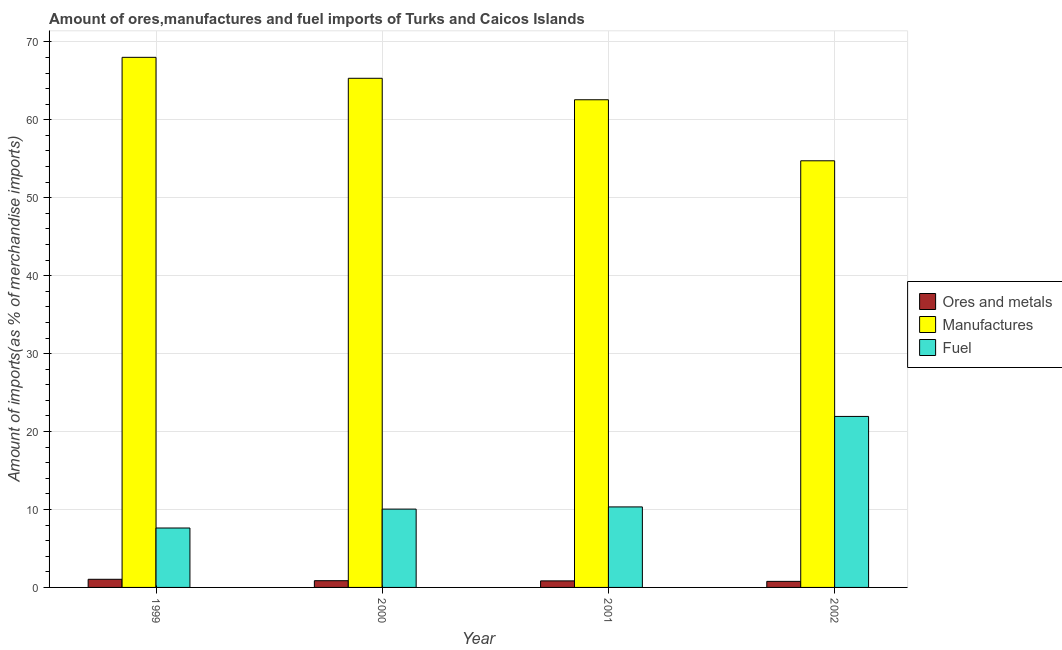How many different coloured bars are there?
Ensure brevity in your answer.  3. Are the number of bars on each tick of the X-axis equal?
Make the answer very short. Yes. How many bars are there on the 2nd tick from the left?
Offer a terse response. 3. How many bars are there on the 3rd tick from the right?
Make the answer very short. 3. What is the label of the 2nd group of bars from the left?
Your answer should be very brief. 2000. What is the percentage of manufactures imports in 2000?
Make the answer very short. 65.32. Across all years, what is the maximum percentage of fuel imports?
Your answer should be very brief. 21.94. Across all years, what is the minimum percentage of manufactures imports?
Give a very brief answer. 54.74. In which year was the percentage of ores and metals imports maximum?
Offer a terse response. 1999. What is the total percentage of manufactures imports in the graph?
Provide a succinct answer. 250.65. What is the difference between the percentage of manufactures imports in 2001 and that in 2002?
Offer a terse response. 7.83. What is the difference between the percentage of manufactures imports in 2001 and the percentage of fuel imports in 2002?
Provide a succinct answer. 7.83. What is the average percentage of ores and metals imports per year?
Make the answer very short. 0.88. In the year 2001, what is the difference between the percentage of fuel imports and percentage of ores and metals imports?
Ensure brevity in your answer.  0. What is the ratio of the percentage of manufactures imports in 1999 to that in 2000?
Provide a short and direct response. 1.04. What is the difference between the highest and the second highest percentage of fuel imports?
Your response must be concise. 11.61. What is the difference between the highest and the lowest percentage of fuel imports?
Your answer should be very brief. 14.31. Is the sum of the percentage of manufactures imports in 1999 and 2002 greater than the maximum percentage of ores and metals imports across all years?
Provide a succinct answer. Yes. What does the 1st bar from the left in 1999 represents?
Make the answer very short. Ores and metals. What does the 2nd bar from the right in 1999 represents?
Your response must be concise. Manufactures. How many years are there in the graph?
Your answer should be compact. 4. Does the graph contain grids?
Make the answer very short. Yes. What is the title of the graph?
Your response must be concise. Amount of ores,manufactures and fuel imports of Turks and Caicos Islands. Does "Slovak Republic" appear as one of the legend labels in the graph?
Provide a short and direct response. No. What is the label or title of the Y-axis?
Your response must be concise. Amount of imports(as % of merchandise imports). What is the Amount of imports(as % of merchandise imports) in Ores and metals in 1999?
Offer a very short reply. 1.04. What is the Amount of imports(as % of merchandise imports) of Manufactures in 1999?
Make the answer very short. 68.01. What is the Amount of imports(as % of merchandise imports) of Fuel in 1999?
Offer a terse response. 7.62. What is the Amount of imports(as % of merchandise imports) in Ores and metals in 2000?
Provide a short and direct response. 0.86. What is the Amount of imports(as % of merchandise imports) in Manufactures in 2000?
Your answer should be very brief. 65.32. What is the Amount of imports(as % of merchandise imports) of Fuel in 2000?
Give a very brief answer. 10.05. What is the Amount of imports(as % of merchandise imports) of Ores and metals in 2001?
Your response must be concise. 0.84. What is the Amount of imports(as % of merchandise imports) in Manufactures in 2001?
Your answer should be very brief. 62.57. What is the Amount of imports(as % of merchandise imports) of Fuel in 2001?
Provide a succinct answer. 10.33. What is the Amount of imports(as % of merchandise imports) in Ores and metals in 2002?
Provide a short and direct response. 0.78. What is the Amount of imports(as % of merchandise imports) of Manufactures in 2002?
Provide a succinct answer. 54.74. What is the Amount of imports(as % of merchandise imports) in Fuel in 2002?
Make the answer very short. 21.94. Across all years, what is the maximum Amount of imports(as % of merchandise imports) in Ores and metals?
Give a very brief answer. 1.04. Across all years, what is the maximum Amount of imports(as % of merchandise imports) of Manufactures?
Your answer should be very brief. 68.01. Across all years, what is the maximum Amount of imports(as % of merchandise imports) in Fuel?
Ensure brevity in your answer.  21.94. Across all years, what is the minimum Amount of imports(as % of merchandise imports) of Ores and metals?
Give a very brief answer. 0.78. Across all years, what is the minimum Amount of imports(as % of merchandise imports) of Manufactures?
Offer a very short reply. 54.74. Across all years, what is the minimum Amount of imports(as % of merchandise imports) in Fuel?
Provide a succinct answer. 7.62. What is the total Amount of imports(as % of merchandise imports) of Ores and metals in the graph?
Provide a short and direct response. 3.52. What is the total Amount of imports(as % of merchandise imports) in Manufactures in the graph?
Offer a very short reply. 250.65. What is the total Amount of imports(as % of merchandise imports) in Fuel in the graph?
Provide a short and direct response. 49.94. What is the difference between the Amount of imports(as % of merchandise imports) in Ores and metals in 1999 and that in 2000?
Your answer should be compact. 0.18. What is the difference between the Amount of imports(as % of merchandise imports) of Manufactures in 1999 and that in 2000?
Make the answer very short. 2.69. What is the difference between the Amount of imports(as % of merchandise imports) in Fuel in 1999 and that in 2000?
Your answer should be compact. -2.43. What is the difference between the Amount of imports(as % of merchandise imports) in Ores and metals in 1999 and that in 2001?
Your response must be concise. 0.2. What is the difference between the Amount of imports(as % of merchandise imports) of Manufactures in 1999 and that in 2001?
Offer a terse response. 5.44. What is the difference between the Amount of imports(as % of merchandise imports) of Fuel in 1999 and that in 2001?
Make the answer very short. -2.71. What is the difference between the Amount of imports(as % of merchandise imports) of Ores and metals in 1999 and that in 2002?
Make the answer very short. 0.27. What is the difference between the Amount of imports(as % of merchandise imports) of Manufactures in 1999 and that in 2002?
Your response must be concise. 13.27. What is the difference between the Amount of imports(as % of merchandise imports) of Fuel in 1999 and that in 2002?
Offer a terse response. -14.31. What is the difference between the Amount of imports(as % of merchandise imports) in Ores and metals in 2000 and that in 2001?
Provide a short and direct response. 0.02. What is the difference between the Amount of imports(as % of merchandise imports) in Manufactures in 2000 and that in 2001?
Make the answer very short. 2.75. What is the difference between the Amount of imports(as % of merchandise imports) of Fuel in 2000 and that in 2001?
Your response must be concise. -0.28. What is the difference between the Amount of imports(as % of merchandise imports) of Ores and metals in 2000 and that in 2002?
Ensure brevity in your answer.  0.08. What is the difference between the Amount of imports(as % of merchandise imports) of Manufactures in 2000 and that in 2002?
Give a very brief answer. 10.58. What is the difference between the Amount of imports(as % of merchandise imports) of Fuel in 2000 and that in 2002?
Keep it short and to the point. -11.89. What is the difference between the Amount of imports(as % of merchandise imports) in Ores and metals in 2001 and that in 2002?
Your response must be concise. 0.06. What is the difference between the Amount of imports(as % of merchandise imports) of Manufactures in 2001 and that in 2002?
Keep it short and to the point. 7.83. What is the difference between the Amount of imports(as % of merchandise imports) in Fuel in 2001 and that in 2002?
Ensure brevity in your answer.  -11.61. What is the difference between the Amount of imports(as % of merchandise imports) of Ores and metals in 1999 and the Amount of imports(as % of merchandise imports) of Manufactures in 2000?
Make the answer very short. -64.28. What is the difference between the Amount of imports(as % of merchandise imports) in Ores and metals in 1999 and the Amount of imports(as % of merchandise imports) in Fuel in 2000?
Ensure brevity in your answer.  -9. What is the difference between the Amount of imports(as % of merchandise imports) in Manufactures in 1999 and the Amount of imports(as % of merchandise imports) in Fuel in 2000?
Make the answer very short. 57.96. What is the difference between the Amount of imports(as % of merchandise imports) of Ores and metals in 1999 and the Amount of imports(as % of merchandise imports) of Manufactures in 2001?
Provide a short and direct response. -61.53. What is the difference between the Amount of imports(as % of merchandise imports) in Ores and metals in 1999 and the Amount of imports(as % of merchandise imports) in Fuel in 2001?
Your response must be concise. -9.29. What is the difference between the Amount of imports(as % of merchandise imports) of Manufactures in 1999 and the Amount of imports(as % of merchandise imports) of Fuel in 2001?
Make the answer very short. 57.68. What is the difference between the Amount of imports(as % of merchandise imports) in Ores and metals in 1999 and the Amount of imports(as % of merchandise imports) in Manufactures in 2002?
Make the answer very short. -53.7. What is the difference between the Amount of imports(as % of merchandise imports) in Ores and metals in 1999 and the Amount of imports(as % of merchandise imports) in Fuel in 2002?
Offer a terse response. -20.89. What is the difference between the Amount of imports(as % of merchandise imports) in Manufactures in 1999 and the Amount of imports(as % of merchandise imports) in Fuel in 2002?
Give a very brief answer. 46.07. What is the difference between the Amount of imports(as % of merchandise imports) of Ores and metals in 2000 and the Amount of imports(as % of merchandise imports) of Manufactures in 2001?
Your answer should be very brief. -61.71. What is the difference between the Amount of imports(as % of merchandise imports) in Ores and metals in 2000 and the Amount of imports(as % of merchandise imports) in Fuel in 2001?
Make the answer very short. -9.47. What is the difference between the Amount of imports(as % of merchandise imports) in Manufactures in 2000 and the Amount of imports(as % of merchandise imports) in Fuel in 2001?
Give a very brief answer. 55. What is the difference between the Amount of imports(as % of merchandise imports) in Ores and metals in 2000 and the Amount of imports(as % of merchandise imports) in Manufactures in 2002?
Your answer should be very brief. -53.88. What is the difference between the Amount of imports(as % of merchandise imports) of Ores and metals in 2000 and the Amount of imports(as % of merchandise imports) of Fuel in 2002?
Ensure brevity in your answer.  -21.08. What is the difference between the Amount of imports(as % of merchandise imports) in Manufactures in 2000 and the Amount of imports(as % of merchandise imports) in Fuel in 2002?
Your answer should be very brief. 43.39. What is the difference between the Amount of imports(as % of merchandise imports) of Ores and metals in 2001 and the Amount of imports(as % of merchandise imports) of Manufactures in 2002?
Provide a succinct answer. -53.9. What is the difference between the Amount of imports(as % of merchandise imports) in Ores and metals in 2001 and the Amount of imports(as % of merchandise imports) in Fuel in 2002?
Make the answer very short. -21.1. What is the difference between the Amount of imports(as % of merchandise imports) of Manufactures in 2001 and the Amount of imports(as % of merchandise imports) of Fuel in 2002?
Make the answer very short. 40.63. What is the average Amount of imports(as % of merchandise imports) of Ores and metals per year?
Your response must be concise. 0.88. What is the average Amount of imports(as % of merchandise imports) in Manufactures per year?
Your answer should be very brief. 62.66. What is the average Amount of imports(as % of merchandise imports) of Fuel per year?
Offer a terse response. 12.49. In the year 1999, what is the difference between the Amount of imports(as % of merchandise imports) of Ores and metals and Amount of imports(as % of merchandise imports) of Manufactures?
Your response must be concise. -66.97. In the year 1999, what is the difference between the Amount of imports(as % of merchandise imports) in Ores and metals and Amount of imports(as % of merchandise imports) in Fuel?
Keep it short and to the point. -6.58. In the year 1999, what is the difference between the Amount of imports(as % of merchandise imports) in Manufactures and Amount of imports(as % of merchandise imports) in Fuel?
Make the answer very short. 60.39. In the year 2000, what is the difference between the Amount of imports(as % of merchandise imports) in Ores and metals and Amount of imports(as % of merchandise imports) in Manufactures?
Make the answer very short. -64.46. In the year 2000, what is the difference between the Amount of imports(as % of merchandise imports) of Ores and metals and Amount of imports(as % of merchandise imports) of Fuel?
Your answer should be very brief. -9.19. In the year 2000, what is the difference between the Amount of imports(as % of merchandise imports) in Manufactures and Amount of imports(as % of merchandise imports) in Fuel?
Give a very brief answer. 55.28. In the year 2001, what is the difference between the Amount of imports(as % of merchandise imports) in Ores and metals and Amount of imports(as % of merchandise imports) in Manufactures?
Keep it short and to the point. -61.73. In the year 2001, what is the difference between the Amount of imports(as % of merchandise imports) of Ores and metals and Amount of imports(as % of merchandise imports) of Fuel?
Keep it short and to the point. -9.49. In the year 2001, what is the difference between the Amount of imports(as % of merchandise imports) of Manufactures and Amount of imports(as % of merchandise imports) of Fuel?
Offer a terse response. 52.24. In the year 2002, what is the difference between the Amount of imports(as % of merchandise imports) in Ores and metals and Amount of imports(as % of merchandise imports) in Manufactures?
Offer a terse response. -53.96. In the year 2002, what is the difference between the Amount of imports(as % of merchandise imports) in Ores and metals and Amount of imports(as % of merchandise imports) in Fuel?
Your answer should be very brief. -21.16. In the year 2002, what is the difference between the Amount of imports(as % of merchandise imports) of Manufactures and Amount of imports(as % of merchandise imports) of Fuel?
Keep it short and to the point. 32.8. What is the ratio of the Amount of imports(as % of merchandise imports) of Ores and metals in 1999 to that in 2000?
Provide a succinct answer. 1.21. What is the ratio of the Amount of imports(as % of merchandise imports) in Manufactures in 1999 to that in 2000?
Provide a succinct answer. 1.04. What is the ratio of the Amount of imports(as % of merchandise imports) of Fuel in 1999 to that in 2000?
Your response must be concise. 0.76. What is the ratio of the Amount of imports(as % of merchandise imports) in Ores and metals in 1999 to that in 2001?
Make the answer very short. 1.24. What is the ratio of the Amount of imports(as % of merchandise imports) of Manufactures in 1999 to that in 2001?
Provide a short and direct response. 1.09. What is the ratio of the Amount of imports(as % of merchandise imports) in Fuel in 1999 to that in 2001?
Your response must be concise. 0.74. What is the ratio of the Amount of imports(as % of merchandise imports) in Ores and metals in 1999 to that in 2002?
Your answer should be compact. 1.34. What is the ratio of the Amount of imports(as % of merchandise imports) of Manufactures in 1999 to that in 2002?
Provide a succinct answer. 1.24. What is the ratio of the Amount of imports(as % of merchandise imports) of Fuel in 1999 to that in 2002?
Provide a succinct answer. 0.35. What is the ratio of the Amount of imports(as % of merchandise imports) of Ores and metals in 2000 to that in 2001?
Offer a very short reply. 1.03. What is the ratio of the Amount of imports(as % of merchandise imports) in Manufactures in 2000 to that in 2001?
Keep it short and to the point. 1.04. What is the ratio of the Amount of imports(as % of merchandise imports) in Fuel in 2000 to that in 2001?
Make the answer very short. 0.97. What is the ratio of the Amount of imports(as % of merchandise imports) of Ores and metals in 2000 to that in 2002?
Keep it short and to the point. 1.11. What is the ratio of the Amount of imports(as % of merchandise imports) in Manufactures in 2000 to that in 2002?
Your answer should be very brief. 1.19. What is the ratio of the Amount of imports(as % of merchandise imports) of Fuel in 2000 to that in 2002?
Offer a very short reply. 0.46. What is the ratio of the Amount of imports(as % of merchandise imports) in Ores and metals in 2001 to that in 2002?
Provide a short and direct response. 1.08. What is the ratio of the Amount of imports(as % of merchandise imports) of Manufactures in 2001 to that in 2002?
Your answer should be very brief. 1.14. What is the ratio of the Amount of imports(as % of merchandise imports) of Fuel in 2001 to that in 2002?
Ensure brevity in your answer.  0.47. What is the difference between the highest and the second highest Amount of imports(as % of merchandise imports) in Ores and metals?
Keep it short and to the point. 0.18. What is the difference between the highest and the second highest Amount of imports(as % of merchandise imports) in Manufactures?
Offer a very short reply. 2.69. What is the difference between the highest and the second highest Amount of imports(as % of merchandise imports) of Fuel?
Offer a terse response. 11.61. What is the difference between the highest and the lowest Amount of imports(as % of merchandise imports) in Ores and metals?
Provide a short and direct response. 0.27. What is the difference between the highest and the lowest Amount of imports(as % of merchandise imports) in Manufactures?
Make the answer very short. 13.27. What is the difference between the highest and the lowest Amount of imports(as % of merchandise imports) in Fuel?
Make the answer very short. 14.31. 